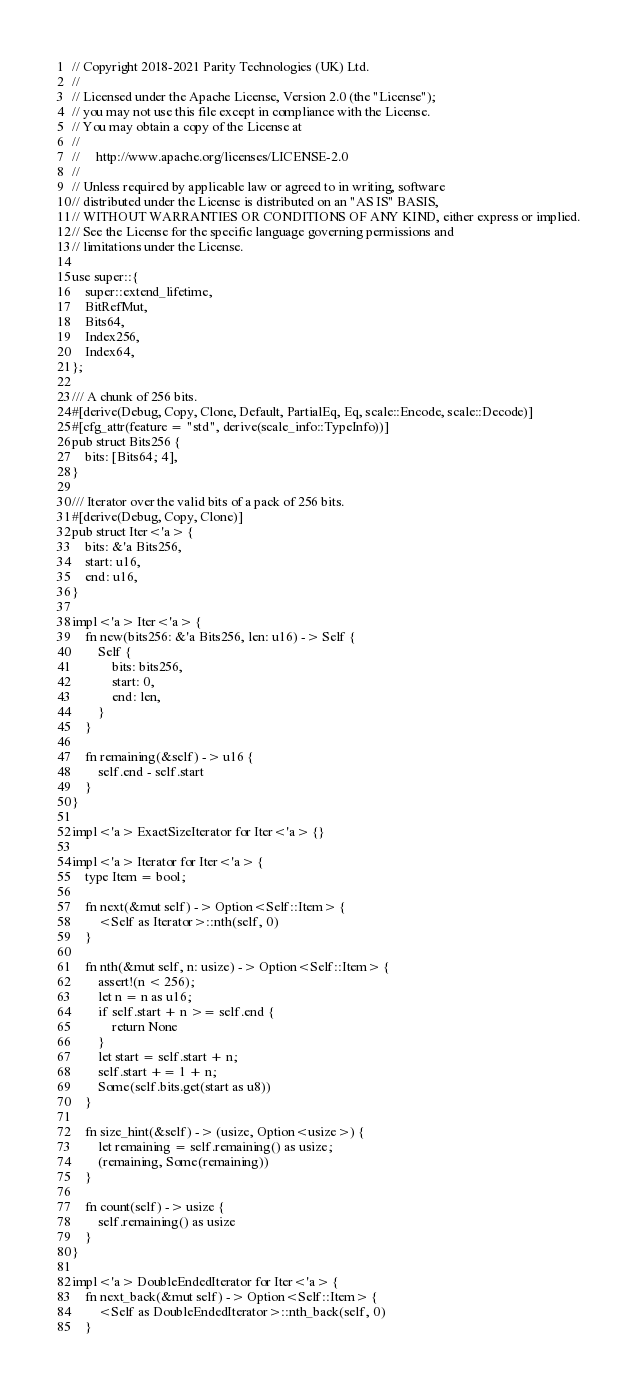<code> <loc_0><loc_0><loc_500><loc_500><_Rust_>// Copyright 2018-2021 Parity Technologies (UK) Ltd.
//
// Licensed under the Apache License, Version 2.0 (the "License");
// you may not use this file except in compliance with the License.
// You may obtain a copy of the License at
//
//     http://www.apache.org/licenses/LICENSE-2.0
//
// Unless required by applicable law or agreed to in writing, software
// distributed under the License is distributed on an "AS IS" BASIS,
// WITHOUT WARRANTIES OR CONDITIONS OF ANY KIND, either express or implied.
// See the License for the specific language governing permissions and
// limitations under the License.

use super::{
    super::extend_lifetime,
    BitRefMut,
    Bits64,
    Index256,
    Index64,
};

/// A chunk of 256 bits.
#[derive(Debug, Copy, Clone, Default, PartialEq, Eq, scale::Encode, scale::Decode)]
#[cfg_attr(feature = "std", derive(scale_info::TypeInfo))]
pub struct Bits256 {
    bits: [Bits64; 4],
}

/// Iterator over the valid bits of a pack of 256 bits.
#[derive(Debug, Copy, Clone)]
pub struct Iter<'a> {
    bits: &'a Bits256,
    start: u16,
    end: u16,
}

impl<'a> Iter<'a> {
    fn new(bits256: &'a Bits256, len: u16) -> Self {
        Self {
            bits: bits256,
            start: 0,
            end: len,
        }
    }

    fn remaining(&self) -> u16 {
        self.end - self.start
    }
}

impl<'a> ExactSizeIterator for Iter<'a> {}

impl<'a> Iterator for Iter<'a> {
    type Item = bool;

    fn next(&mut self) -> Option<Self::Item> {
        <Self as Iterator>::nth(self, 0)
    }

    fn nth(&mut self, n: usize) -> Option<Self::Item> {
        assert!(n < 256);
        let n = n as u16;
        if self.start + n >= self.end {
            return None
        }
        let start = self.start + n;
        self.start += 1 + n;
        Some(self.bits.get(start as u8))
    }

    fn size_hint(&self) -> (usize, Option<usize>) {
        let remaining = self.remaining() as usize;
        (remaining, Some(remaining))
    }

    fn count(self) -> usize {
        self.remaining() as usize
    }
}

impl<'a> DoubleEndedIterator for Iter<'a> {
    fn next_back(&mut self) -> Option<Self::Item> {
        <Self as DoubleEndedIterator>::nth_back(self, 0)
    }
</code> 